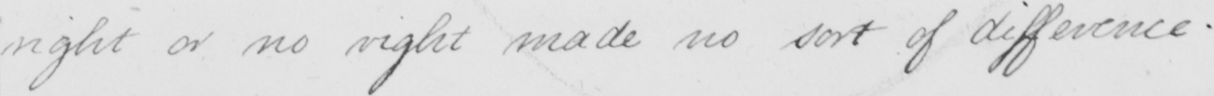Can you read and transcribe this handwriting? right or no right made no sort of difference . 